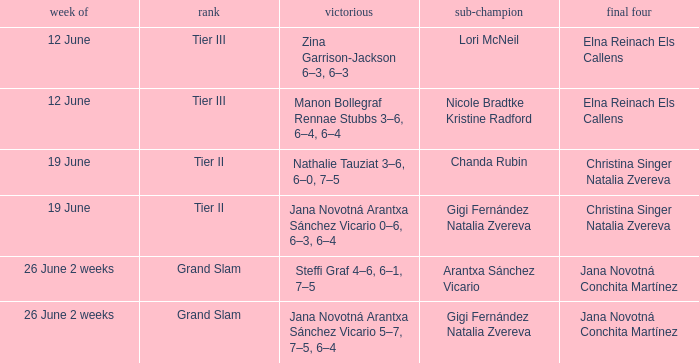In which week is the winner listed as Jana Novotná Arantxa Sánchez Vicario 5–7, 7–5, 6–4? 26 June 2 weeks. 